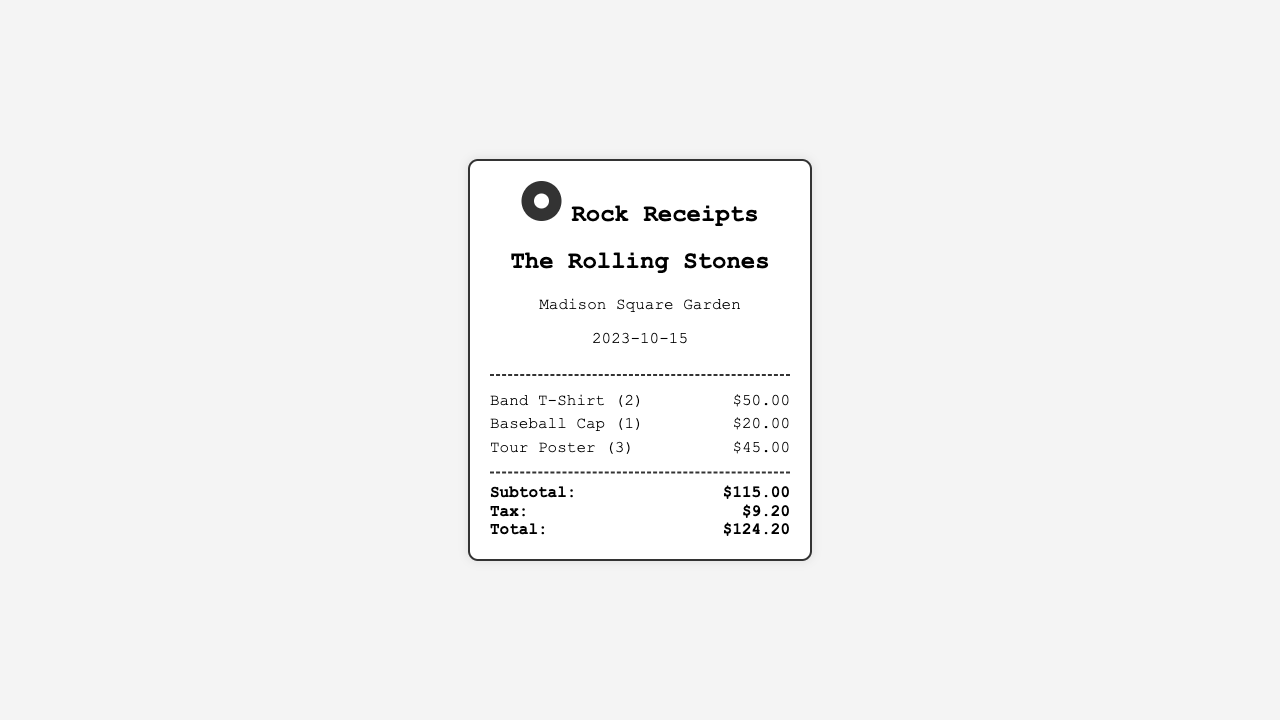What is the date of the concert? The concert date is shown in the document as the performance date, which is 2023-10-15.
Answer: 2023-10-15 How many Band T-Shirts were purchased? The receipt lists the quantity of Band T-Shirts purchased as 2.
Answer: 2 What is the price of the Baseball Cap? The price for the Baseball Cap is stated clearly in the items section, which is $20.00.
Answer: $20.00 What is the subtotal amount? The subtotal amount is detailed at the bottom of the items section and totals $115.00.
Answer: $115.00 What is the total amount after tax? The total amount listed in the document after tax is the sum of the subtotal and tax, which is $124.20.
Answer: $124.20 How many Tour Posters were bought? The quantity of Tour Posters purchased is indicated as 3 in the items section of the receipt.
Answer: 3 What is the tax amount? The tax amount is shown in the totals section, which is $9.20.
Answer: $9.20 What venue hosted the concert? The venue for the concert is mentioned at the top of the receipt as Madison Square Garden.
Answer: Madison Square Garden What type of merchandise is sold? The merchandise sold includes items such as T-Shirts, Baseball Caps, and Tour Posters as listed in the items section.
Answer: T-Shirts, Baseball Caps, Tour Posters 